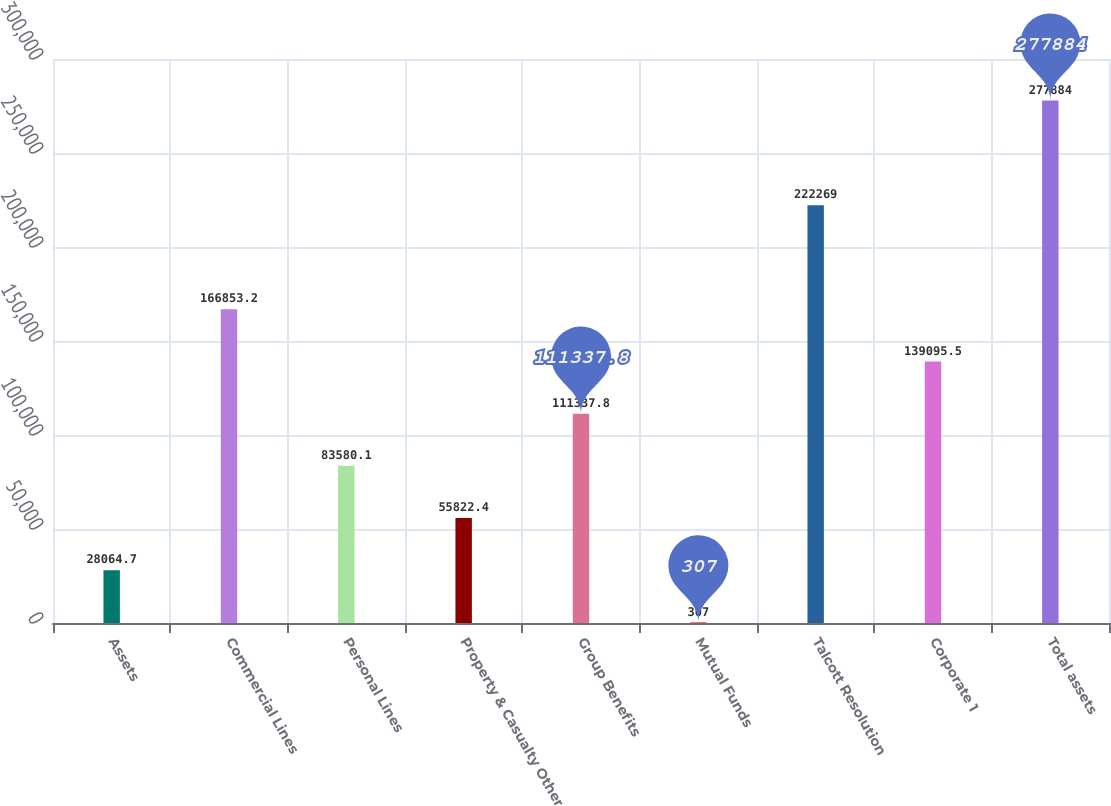<chart> <loc_0><loc_0><loc_500><loc_500><bar_chart><fcel>Assets<fcel>Commercial Lines<fcel>Personal Lines<fcel>Property & Casualty Other<fcel>Group Benefits<fcel>Mutual Funds<fcel>Talcott Resolution<fcel>Corporate 1<fcel>Total assets<nl><fcel>28064.7<fcel>166853<fcel>83580.1<fcel>55822.4<fcel>111338<fcel>307<fcel>222269<fcel>139096<fcel>277884<nl></chart> 